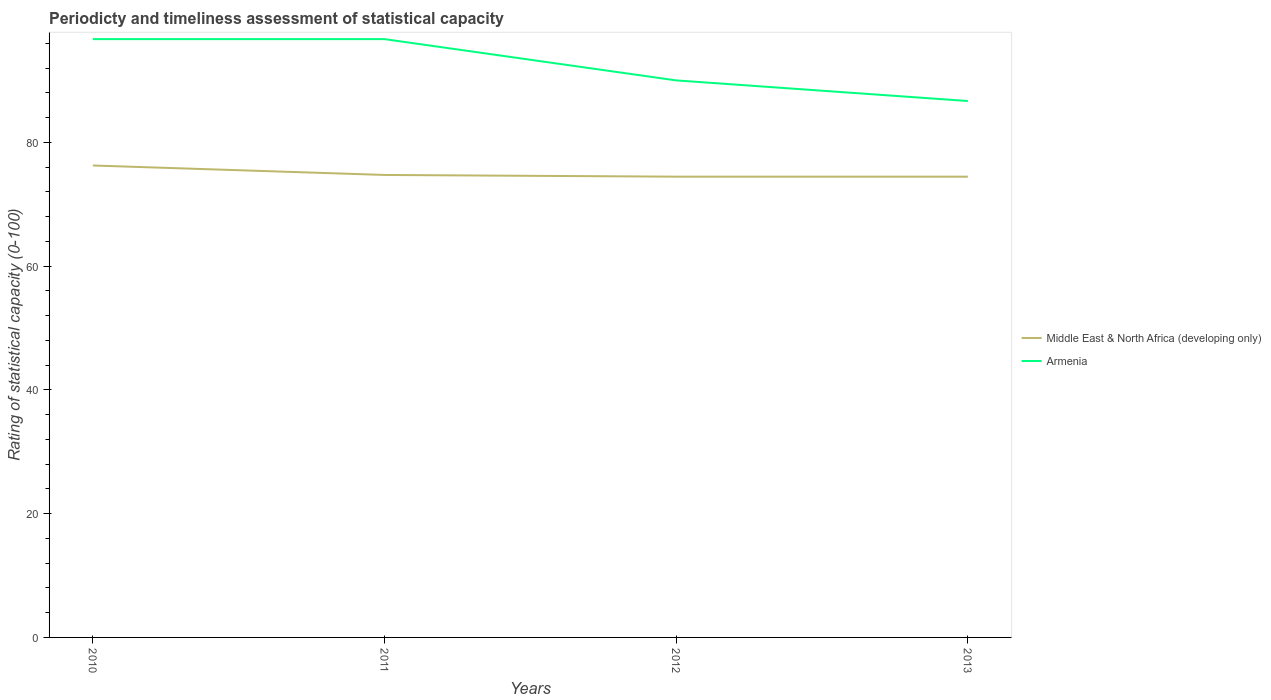Across all years, what is the maximum rating of statistical capacity in Middle East & North Africa (developing only)?
Give a very brief answer. 74.44. In which year was the rating of statistical capacity in Middle East & North Africa (developing only) maximum?
Offer a very short reply. 2013. What is the total rating of statistical capacity in Armenia in the graph?
Your response must be concise. 3.33. What is the difference between the highest and the second highest rating of statistical capacity in Middle East & North Africa (developing only)?
Your answer should be compact. 1.81. What is the difference between the highest and the lowest rating of statistical capacity in Armenia?
Your answer should be compact. 2. Are the values on the major ticks of Y-axis written in scientific E-notation?
Your response must be concise. No. Where does the legend appear in the graph?
Your response must be concise. Center right. How are the legend labels stacked?
Offer a terse response. Vertical. What is the title of the graph?
Give a very brief answer. Periodicty and timeliness assessment of statistical capacity. What is the label or title of the X-axis?
Give a very brief answer. Years. What is the label or title of the Y-axis?
Offer a very short reply. Rating of statistical capacity (0-100). What is the Rating of statistical capacity (0-100) in Middle East & North Africa (developing only) in 2010?
Make the answer very short. 76.25. What is the Rating of statistical capacity (0-100) of Armenia in 2010?
Your answer should be very brief. 96.67. What is the Rating of statistical capacity (0-100) of Middle East & North Africa (developing only) in 2011?
Your answer should be compact. 74.72. What is the Rating of statistical capacity (0-100) in Armenia in 2011?
Provide a succinct answer. 96.67. What is the Rating of statistical capacity (0-100) of Middle East & North Africa (developing only) in 2012?
Your answer should be very brief. 74.44. What is the Rating of statistical capacity (0-100) in Middle East & North Africa (developing only) in 2013?
Provide a succinct answer. 74.44. What is the Rating of statistical capacity (0-100) of Armenia in 2013?
Provide a succinct answer. 86.67. Across all years, what is the maximum Rating of statistical capacity (0-100) in Middle East & North Africa (developing only)?
Offer a terse response. 76.25. Across all years, what is the maximum Rating of statistical capacity (0-100) of Armenia?
Offer a very short reply. 96.67. Across all years, what is the minimum Rating of statistical capacity (0-100) of Middle East & North Africa (developing only)?
Ensure brevity in your answer.  74.44. Across all years, what is the minimum Rating of statistical capacity (0-100) in Armenia?
Offer a very short reply. 86.67. What is the total Rating of statistical capacity (0-100) of Middle East & North Africa (developing only) in the graph?
Give a very brief answer. 299.86. What is the total Rating of statistical capacity (0-100) of Armenia in the graph?
Offer a very short reply. 370. What is the difference between the Rating of statistical capacity (0-100) in Middle East & North Africa (developing only) in 2010 and that in 2011?
Offer a very short reply. 1.53. What is the difference between the Rating of statistical capacity (0-100) in Armenia in 2010 and that in 2011?
Your answer should be very brief. 0. What is the difference between the Rating of statistical capacity (0-100) of Middle East & North Africa (developing only) in 2010 and that in 2012?
Keep it short and to the point. 1.81. What is the difference between the Rating of statistical capacity (0-100) of Armenia in 2010 and that in 2012?
Provide a short and direct response. 6.67. What is the difference between the Rating of statistical capacity (0-100) of Middle East & North Africa (developing only) in 2010 and that in 2013?
Offer a terse response. 1.81. What is the difference between the Rating of statistical capacity (0-100) of Middle East & North Africa (developing only) in 2011 and that in 2012?
Keep it short and to the point. 0.28. What is the difference between the Rating of statistical capacity (0-100) of Middle East & North Africa (developing only) in 2011 and that in 2013?
Provide a succinct answer. 0.28. What is the difference between the Rating of statistical capacity (0-100) in Armenia in 2011 and that in 2013?
Give a very brief answer. 10. What is the difference between the Rating of statistical capacity (0-100) in Middle East & North Africa (developing only) in 2012 and that in 2013?
Make the answer very short. 0. What is the difference between the Rating of statistical capacity (0-100) of Armenia in 2012 and that in 2013?
Your response must be concise. 3.33. What is the difference between the Rating of statistical capacity (0-100) in Middle East & North Africa (developing only) in 2010 and the Rating of statistical capacity (0-100) in Armenia in 2011?
Offer a very short reply. -20.42. What is the difference between the Rating of statistical capacity (0-100) in Middle East & North Africa (developing only) in 2010 and the Rating of statistical capacity (0-100) in Armenia in 2012?
Ensure brevity in your answer.  -13.75. What is the difference between the Rating of statistical capacity (0-100) in Middle East & North Africa (developing only) in 2010 and the Rating of statistical capacity (0-100) in Armenia in 2013?
Your answer should be very brief. -10.42. What is the difference between the Rating of statistical capacity (0-100) in Middle East & North Africa (developing only) in 2011 and the Rating of statistical capacity (0-100) in Armenia in 2012?
Ensure brevity in your answer.  -15.28. What is the difference between the Rating of statistical capacity (0-100) in Middle East & North Africa (developing only) in 2011 and the Rating of statistical capacity (0-100) in Armenia in 2013?
Give a very brief answer. -11.94. What is the difference between the Rating of statistical capacity (0-100) in Middle East & North Africa (developing only) in 2012 and the Rating of statistical capacity (0-100) in Armenia in 2013?
Provide a succinct answer. -12.22. What is the average Rating of statistical capacity (0-100) in Middle East & North Africa (developing only) per year?
Give a very brief answer. 74.97. What is the average Rating of statistical capacity (0-100) of Armenia per year?
Ensure brevity in your answer.  92.5. In the year 2010, what is the difference between the Rating of statistical capacity (0-100) of Middle East & North Africa (developing only) and Rating of statistical capacity (0-100) of Armenia?
Provide a succinct answer. -20.42. In the year 2011, what is the difference between the Rating of statistical capacity (0-100) in Middle East & North Africa (developing only) and Rating of statistical capacity (0-100) in Armenia?
Make the answer very short. -21.94. In the year 2012, what is the difference between the Rating of statistical capacity (0-100) in Middle East & North Africa (developing only) and Rating of statistical capacity (0-100) in Armenia?
Your answer should be compact. -15.56. In the year 2013, what is the difference between the Rating of statistical capacity (0-100) of Middle East & North Africa (developing only) and Rating of statistical capacity (0-100) of Armenia?
Offer a very short reply. -12.22. What is the ratio of the Rating of statistical capacity (0-100) of Middle East & North Africa (developing only) in 2010 to that in 2011?
Your answer should be very brief. 1.02. What is the ratio of the Rating of statistical capacity (0-100) of Armenia in 2010 to that in 2011?
Provide a short and direct response. 1. What is the ratio of the Rating of statistical capacity (0-100) of Middle East & North Africa (developing only) in 2010 to that in 2012?
Provide a short and direct response. 1.02. What is the ratio of the Rating of statistical capacity (0-100) in Armenia in 2010 to that in 2012?
Ensure brevity in your answer.  1.07. What is the ratio of the Rating of statistical capacity (0-100) in Middle East & North Africa (developing only) in 2010 to that in 2013?
Make the answer very short. 1.02. What is the ratio of the Rating of statistical capacity (0-100) in Armenia in 2010 to that in 2013?
Give a very brief answer. 1.12. What is the ratio of the Rating of statistical capacity (0-100) of Middle East & North Africa (developing only) in 2011 to that in 2012?
Offer a terse response. 1. What is the ratio of the Rating of statistical capacity (0-100) of Armenia in 2011 to that in 2012?
Your answer should be compact. 1.07. What is the ratio of the Rating of statistical capacity (0-100) of Armenia in 2011 to that in 2013?
Offer a terse response. 1.12. What is the ratio of the Rating of statistical capacity (0-100) in Middle East & North Africa (developing only) in 2012 to that in 2013?
Ensure brevity in your answer.  1. What is the ratio of the Rating of statistical capacity (0-100) of Armenia in 2012 to that in 2013?
Keep it short and to the point. 1.04. What is the difference between the highest and the second highest Rating of statistical capacity (0-100) of Middle East & North Africa (developing only)?
Your response must be concise. 1.53. What is the difference between the highest and the lowest Rating of statistical capacity (0-100) of Middle East & North Africa (developing only)?
Provide a succinct answer. 1.81. What is the difference between the highest and the lowest Rating of statistical capacity (0-100) of Armenia?
Offer a very short reply. 10. 